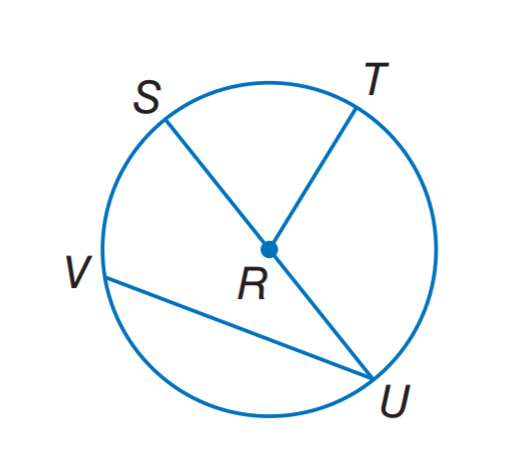Answer the mathemtical geometry problem and directly provide the correct option letter.
Question: In \odot R. If S U = 16.2, what is R T?
Choices: A: 8.1 B: 16.2 C: 24.3 D: 32.4 A 